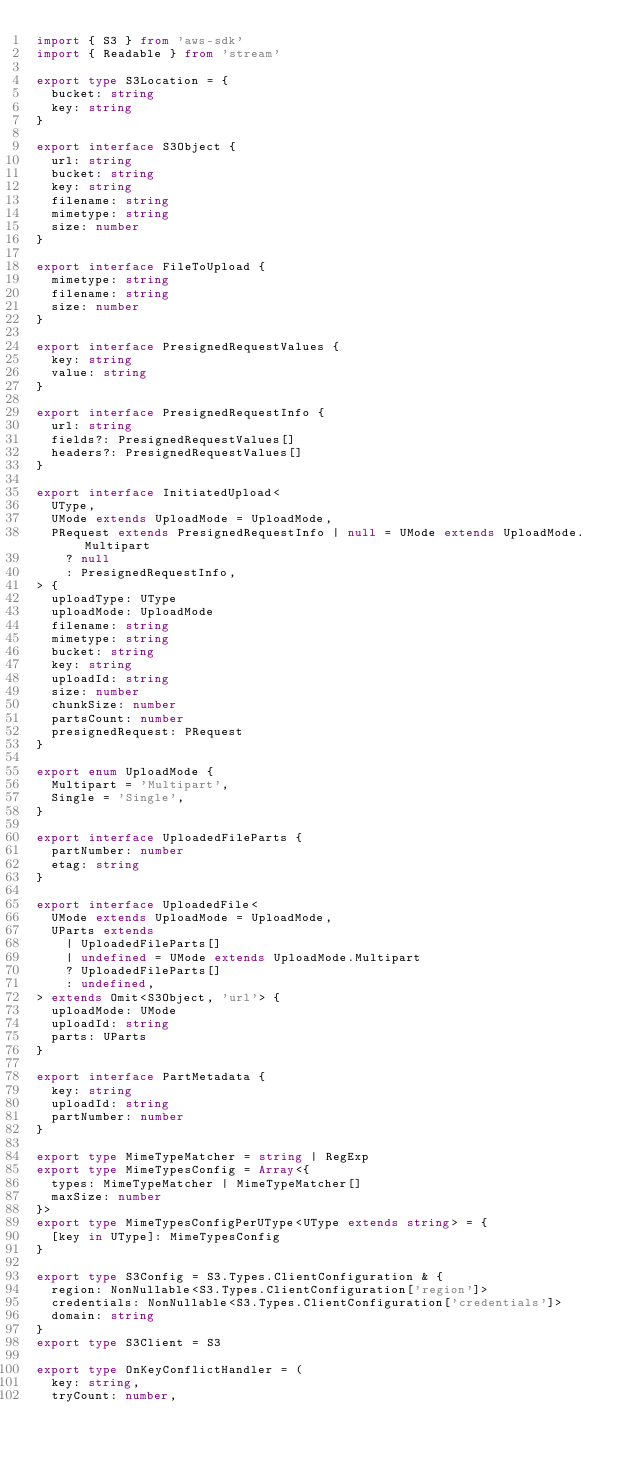Convert code to text. <code><loc_0><loc_0><loc_500><loc_500><_TypeScript_>import { S3 } from 'aws-sdk'
import { Readable } from 'stream'

export type S3Location = {
  bucket: string
  key: string
}

export interface S3Object {
  url: string
  bucket: string
  key: string
  filename: string
  mimetype: string
  size: number
}

export interface FileToUpload {
  mimetype: string
  filename: string
  size: number
}

export interface PresignedRequestValues {
  key: string
  value: string
}

export interface PresignedRequestInfo {
  url: string
  fields?: PresignedRequestValues[]
  headers?: PresignedRequestValues[]
}

export interface InitiatedUpload<
  UType,
  UMode extends UploadMode = UploadMode,
  PRequest extends PresignedRequestInfo | null = UMode extends UploadMode.Multipart
    ? null
    : PresignedRequestInfo,
> {
  uploadType: UType
  uploadMode: UploadMode
  filename: string
  mimetype: string
  bucket: string
  key: string
  uploadId: string
  size: number
  chunkSize: number
  partsCount: number
  presignedRequest: PRequest
}

export enum UploadMode {
  Multipart = 'Multipart',
  Single = 'Single',
}

export interface UploadedFileParts {
  partNumber: number
  etag: string
}

export interface UploadedFile<
  UMode extends UploadMode = UploadMode,
  UParts extends
    | UploadedFileParts[]
    | undefined = UMode extends UploadMode.Multipart
    ? UploadedFileParts[]
    : undefined,
> extends Omit<S3Object, 'url'> {
  uploadMode: UMode
  uploadId: string
  parts: UParts
}

export interface PartMetadata {
  key: string
  uploadId: string
  partNumber: number
}

export type MimeTypeMatcher = string | RegExp
export type MimeTypesConfig = Array<{
  types: MimeTypeMatcher | MimeTypeMatcher[]
  maxSize: number
}>
export type MimeTypesConfigPerUType<UType extends string> = {
  [key in UType]: MimeTypesConfig
}

export type S3Config = S3.Types.ClientConfiguration & {
  region: NonNullable<S3.Types.ClientConfiguration['region']>
  credentials: NonNullable<S3.Types.ClientConfiguration['credentials']>
  domain: string
}
export type S3Client = S3

export type OnKeyConflictHandler = (
  key: string,
  tryCount: number,</code> 